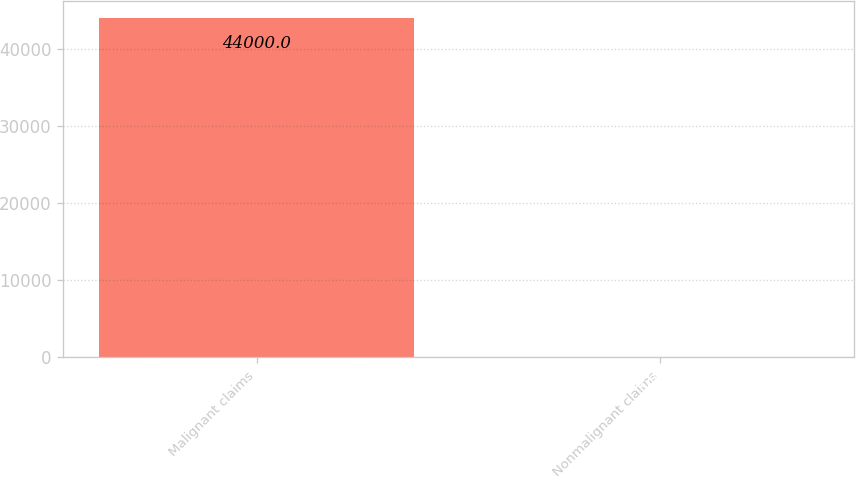Convert chart. <chart><loc_0><loc_0><loc_500><loc_500><bar_chart><fcel>Malignant claims<fcel>Nonmalignant claims<nl><fcel>44000<fcel>100<nl></chart> 